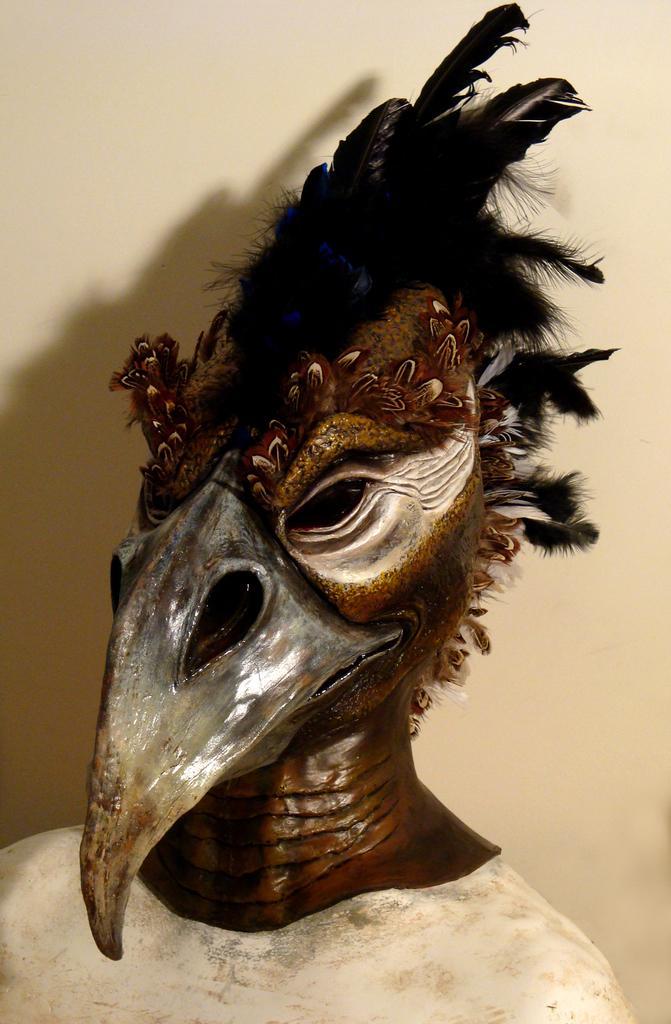Please provide a concise description of this image. In this image there is a sculpture, in the background there is a wall. 